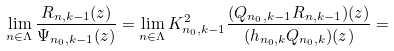<formula> <loc_0><loc_0><loc_500><loc_500>\lim _ { n \in \Lambda } \frac { R _ { n , k - 1 } ( z ) } { \Psi _ { n _ { 0 } , k - 1 } ( z ) } = \lim _ { n \in \Lambda } K _ { n _ { 0 } , k - 1 } ^ { 2 } \frac { ( Q _ { n _ { 0 } , k - 1 } R _ { n , k - 1 } ) ( z ) } { ( h _ { n _ { 0 } , k } Q _ { n _ { 0 } , k } ) ( z ) } =</formula> 